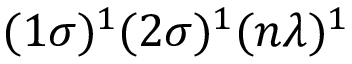<formula> <loc_0><loc_0><loc_500><loc_500>( 1 \sigma ) ^ { 1 } ( 2 \sigma ) ^ { 1 } ( n \lambda ) ^ { 1 }</formula> 